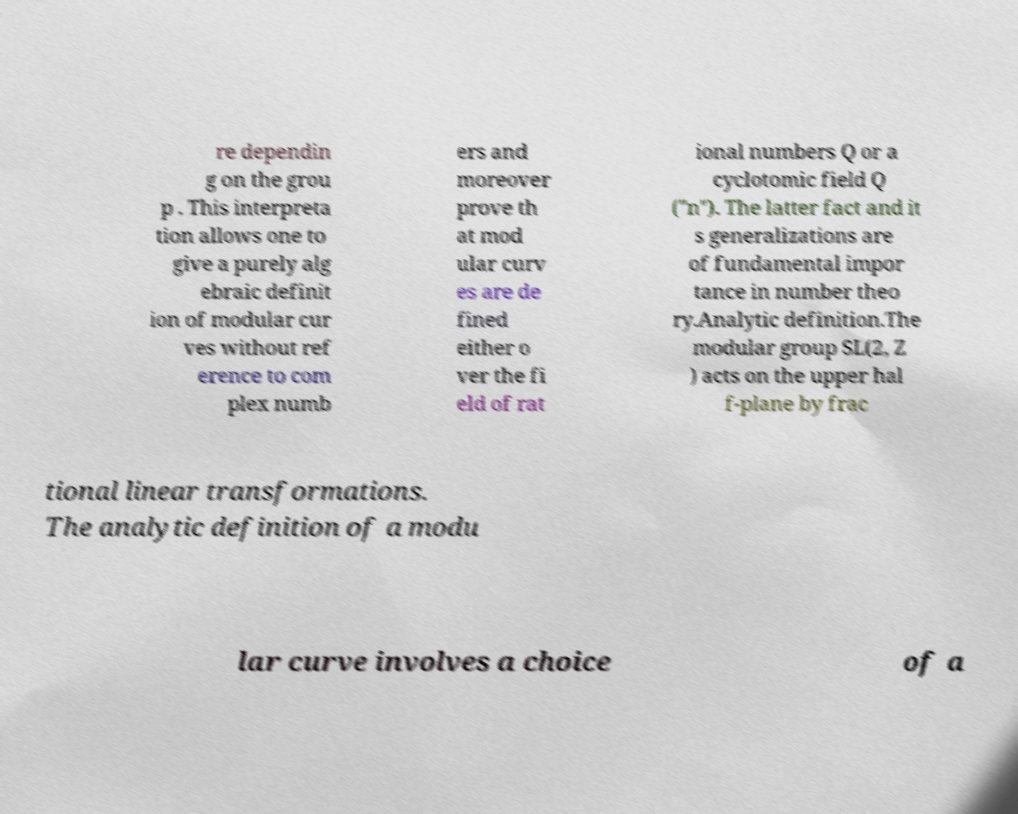Please read and relay the text visible in this image. What does it say? re dependin g on the grou p . This interpreta tion allows one to give a purely alg ebraic definit ion of modular cur ves without ref erence to com plex numb ers and moreover prove th at mod ular curv es are de fined either o ver the fi eld of rat ional numbers Q or a cyclotomic field Q ("n"). The latter fact and it s generalizations are of fundamental impor tance in number theo ry.Analytic definition.The modular group SL(2, Z ) acts on the upper hal f-plane by frac tional linear transformations. The analytic definition of a modu lar curve involves a choice of a 